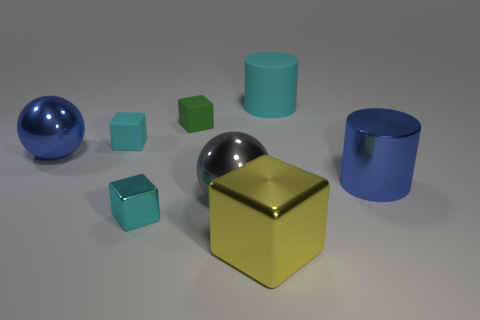What is the size of the cyan cube that is made of the same material as the large gray sphere?
Give a very brief answer. Small. Are there more small green things that are in front of the big gray metal ball than big matte cylinders?
Your answer should be very brief. No. What material is the tiny cube on the left side of the cyan cube in front of the metallic ball on the right side of the cyan shiny block made of?
Your answer should be compact. Rubber. Are the gray thing and the cyan object that is behind the green matte block made of the same material?
Give a very brief answer. No. There is a yellow object that is the same shape as the green matte object; what is it made of?
Your response must be concise. Metal. Are there any other things that are made of the same material as the large yellow cube?
Offer a terse response. Yes. Are there more big gray things to the right of the large cyan matte cylinder than large gray objects that are to the left of the cyan metal cube?
Offer a terse response. No. What shape is the yellow thing that is made of the same material as the big blue sphere?
Provide a succinct answer. Cube. How many other objects are the same shape as the yellow metal object?
Your answer should be very brief. 3. There is a large object to the right of the cyan cylinder; what shape is it?
Ensure brevity in your answer.  Cylinder. 